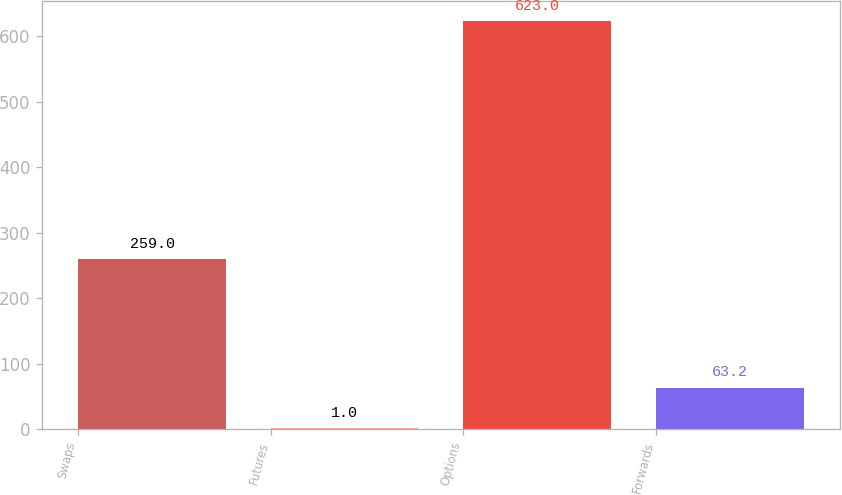<chart> <loc_0><loc_0><loc_500><loc_500><bar_chart><fcel>Swaps<fcel>Futures<fcel>Options<fcel>Forwards<nl><fcel>259<fcel>1<fcel>623<fcel>63.2<nl></chart> 